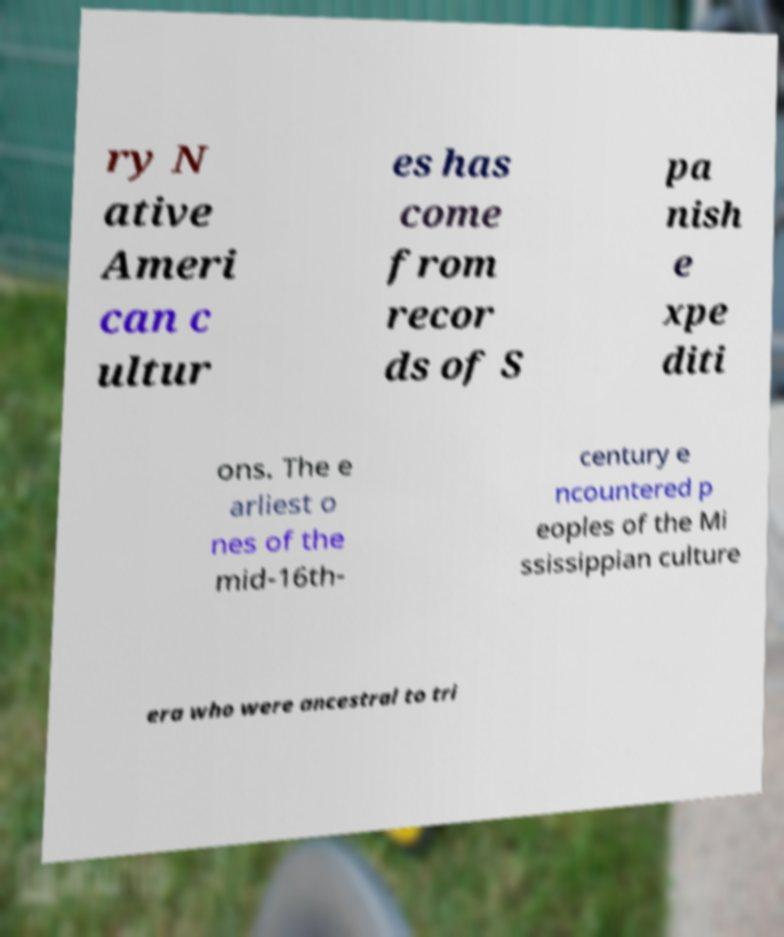Please read and relay the text visible in this image. What does it say? ry N ative Ameri can c ultur es has come from recor ds of S pa nish e xpe diti ons. The e arliest o nes of the mid-16th- century e ncountered p eoples of the Mi ssissippian culture era who were ancestral to tri 